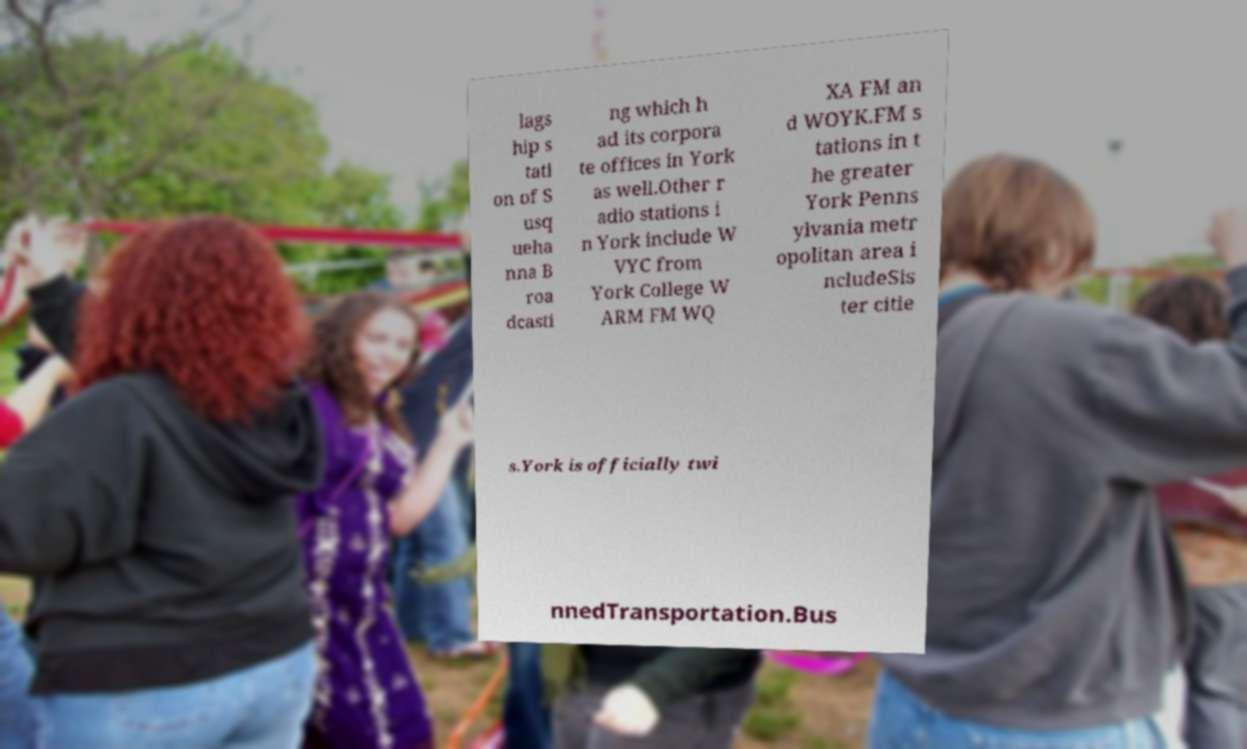Could you assist in decoding the text presented in this image and type it out clearly? lags hip s tati on of S usq ueha nna B roa dcasti ng which h ad its corpora te offices in York as well.Other r adio stations i n York include W VYC from York College W ARM FM WQ XA FM an d WOYK.FM s tations in t he greater York Penns ylvania metr opolitan area i ncludeSis ter citie s.York is officially twi nnedTransportation.Bus 